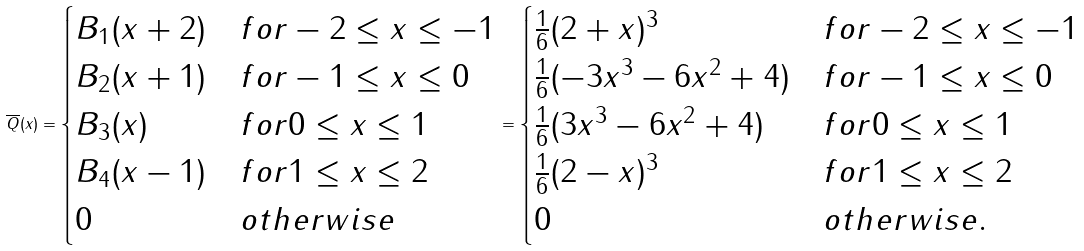Convert formula to latex. <formula><loc_0><loc_0><loc_500><loc_500>\overline { Q } ( x ) = \begin{cases} B _ { 1 } ( x + 2 ) & f o r - 2 \leq x \leq - 1 \\ B _ { 2 } ( x + 1 ) & f o r - 1 \leq x \leq 0 \\ B _ { 3 } ( x ) & f o r 0 \leq x \leq 1 \\ B _ { 4 } ( x - 1 ) & f o r 1 \leq x \leq 2 \\ 0 & o t h e r w i s e \end{cases} = \begin{cases} \frac { 1 } { 6 } ( 2 + x ) ^ { 3 } & f o r - 2 \leq x \leq - 1 \\ \frac { 1 } { 6 } ( - 3 x ^ { 3 } - 6 x ^ { 2 } + 4 ) & f o r - 1 \leq x \leq 0 \\ \frac { 1 } { 6 } ( 3 x ^ { 3 } - 6 x ^ { 2 } + 4 ) & f o r 0 \leq x \leq 1 \\ \frac { 1 } { 6 } ( 2 - x ) ^ { 3 } & f o r 1 \leq x \leq 2 \\ 0 & o t h e r w i s e . \end{cases}</formula> 